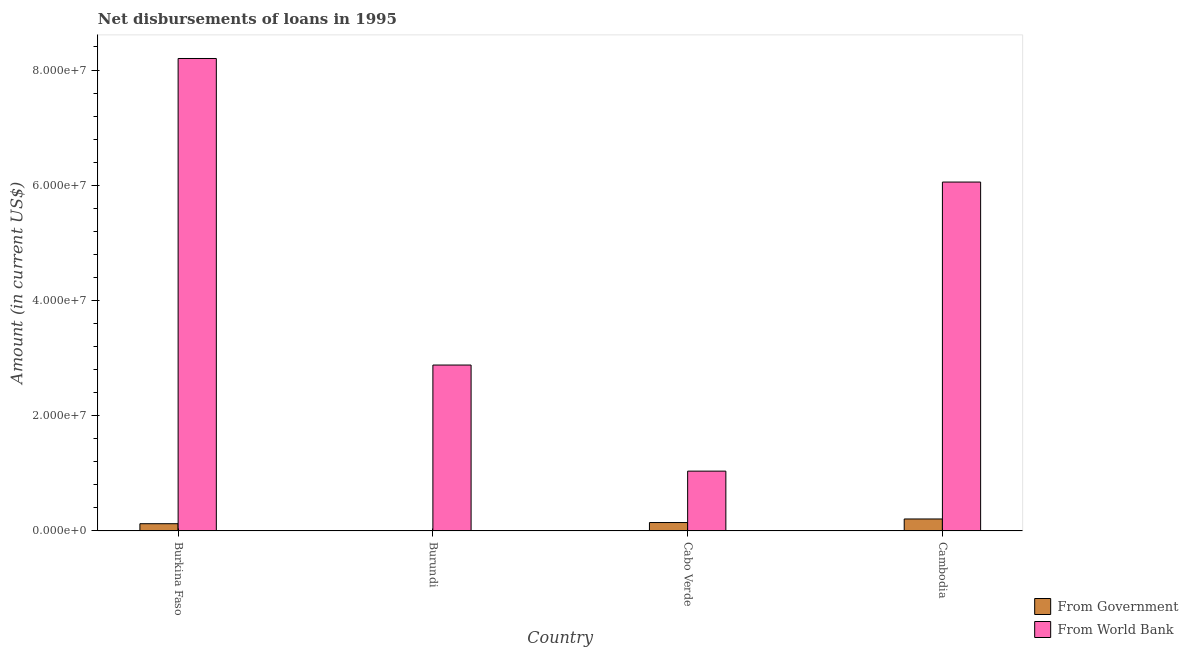Are the number of bars per tick equal to the number of legend labels?
Offer a very short reply. No. How many bars are there on the 4th tick from the left?
Give a very brief answer. 2. How many bars are there on the 3rd tick from the right?
Your response must be concise. 1. What is the label of the 2nd group of bars from the left?
Your answer should be very brief. Burundi. What is the net disbursements of loan from world bank in Cabo Verde?
Your answer should be very brief. 1.04e+07. Across all countries, what is the maximum net disbursements of loan from government?
Keep it short and to the point. 2.08e+06. Across all countries, what is the minimum net disbursements of loan from government?
Your answer should be compact. 0. In which country was the net disbursements of loan from world bank maximum?
Provide a short and direct response. Burkina Faso. What is the total net disbursements of loan from government in the graph?
Provide a short and direct response. 4.79e+06. What is the difference between the net disbursements of loan from world bank in Burundi and that in Cambodia?
Ensure brevity in your answer.  -3.18e+07. What is the difference between the net disbursements of loan from government in Burkina Faso and the net disbursements of loan from world bank in Burundi?
Provide a short and direct response. -2.75e+07. What is the average net disbursements of loan from world bank per country?
Offer a very short reply. 4.54e+07. What is the difference between the net disbursements of loan from world bank and net disbursements of loan from government in Cambodia?
Your answer should be compact. 5.85e+07. What is the ratio of the net disbursements of loan from world bank in Burkina Faso to that in Burundi?
Offer a terse response. 2.85. What is the difference between the highest and the second highest net disbursements of loan from government?
Keep it short and to the point. 6.19e+05. What is the difference between the highest and the lowest net disbursements of loan from government?
Provide a succinct answer. 2.08e+06. In how many countries, is the net disbursements of loan from world bank greater than the average net disbursements of loan from world bank taken over all countries?
Offer a terse response. 2. Is the sum of the net disbursements of loan from world bank in Burundi and Cabo Verde greater than the maximum net disbursements of loan from government across all countries?
Your response must be concise. Yes. Are the values on the major ticks of Y-axis written in scientific E-notation?
Your answer should be compact. Yes. Does the graph contain any zero values?
Offer a very short reply. Yes. Does the graph contain grids?
Provide a short and direct response. No. Where does the legend appear in the graph?
Provide a short and direct response. Bottom right. How many legend labels are there?
Your response must be concise. 2. What is the title of the graph?
Make the answer very short. Net disbursements of loans in 1995. What is the label or title of the X-axis?
Give a very brief answer. Country. What is the Amount (in current US$) of From Government in Burkina Faso?
Offer a terse response. 1.26e+06. What is the Amount (in current US$) in From World Bank in Burkina Faso?
Make the answer very short. 8.20e+07. What is the Amount (in current US$) in From World Bank in Burundi?
Ensure brevity in your answer.  2.88e+07. What is the Amount (in current US$) of From Government in Cabo Verde?
Provide a succinct answer. 1.46e+06. What is the Amount (in current US$) of From World Bank in Cabo Verde?
Your answer should be very brief. 1.04e+07. What is the Amount (in current US$) of From Government in Cambodia?
Ensure brevity in your answer.  2.08e+06. What is the Amount (in current US$) in From World Bank in Cambodia?
Provide a short and direct response. 6.06e+07. Across all countries, what is the maximum Amount (in current US$) of From Government?
Offer a terse response. 2.08e+06. Across all countries, what is the maximum Amount (in current US$) in From World Bank?
Your answer should be very brief. 8.20e+07. Across all countries, what is the minimum Amount (in current US$) of From World Bank?
Your answer should be compact. 1.04e+07. What is the total Amount (in current US$) of From Government in the graph?
Provide a short and direct response. 4.79e+06. What is the total Amount (in current US$) in From World Bank in the graph?
Your answer should be very brief. 1.82e+08. What is the difference between the Amount (in current US$) of From World Bank in Burkina Faso and that in Burundi?
Your response must be concise. 5.32e+07. What is the difference between the Amount (in current US$) of From Government in Burkina Faso and that in Cabo Verde?
Provide a short and direct response. -2.02e+05. What is the difference between the Amount (in current US$) in From World Bank in Burkina Faso and that in Cabo Verde?
Your response must be concise. 7.16e+07. What is the difference between the Amount (in current US$) of From Government in Burkina Faso and that in Cambodia?
Keep it short and to the point. -8.21e+05. What is the difference between the Amount (in current US$) of From World Bank in Burkina Faso and that in Cambodia?
Provide a short and direct response. 2.14e+07. What is the difference between the Amount (in current US$) in From World Bank in Burundi and that in Cabo Verde?
Offer a terse response. 1.84e+07. What is the difference between the Amount (in current US$) of From World Bank in Burundi and that in Cambodia?
Offer a terse response. -3.18e+07. What is the difference between the Amount (in current US$) in From Government in Cabo Verde and that in Cambodia?
Provide a succinct answer. -6.19e+05. What is the difference between the Amount (in current US$) of From World Bank in Cabo Verde and that in Cambodia?
Ensure brevity in your answer.  -5.02e+07. What is the difference between the Amount (in current US$) of From Government in Burkina Faso and the Amount (in current US$) of From World Bank in Burundi?
Keep it short and to the point. -2.75e+07. What is the difference between the Amount (in current US$) in From Government in Burkina Faso and the Amount (in current US$) in From World Bank in Cabo Verde?
Provide a succinct answer. -9.12e+06. What is the difference between the Amount (in current US$) in From Government in Burkina Faso and the Amount (in current US$) in From World Bank in Cambodia?
Give a very brief answer. -5.93e+07. What is the difference between the Amount (in current US$) of From Government in Cabo Verde and the Amount (in current US$) of From World Bank in Cambodia?
Your answer should be very brief. -5.91e+07. What is the average Amount (in current US$) of From Government per country?
Offer a very short reply. 1.20e+06. What is the average Amount (in current US$) of From World Bank per country?
Make the answer very short. 4.54e+07. What is the difference between the Amount (in current US$) in From Government and Amount (in current US$) in From World Bank in Burkina Faso?
Offer a very short reply. -8.07e+07. What is the difference between the Amount (in current US$) of From Government and Amount (in current US$) of From World Bank in Cabo Verde?
Your answer should be very brief. -8.92e+06. What is the difference between the Amount (in current US$) of From Government and Amount (in current US$) of From World Bank in Cambodia?
Your response must be concise. -5.85e+07. What is the ratio of the Amount (in current US$) of From World Bank in Burkina Faso to that in Burundi?
Your response must be concise. 2.85. What is the ratio of the Amount (in current US$) of From Government in Burkina Faso to that in Cabo Verde?
Keep it short and to the point. 0.86. What is the ratio of the Amount (in current US$) of From World Bank in Burkina Faso to that in Cabo Verde?
Your answer should be very brief. 7.9. What is the ratio of the Amount (in current US$) of From Government in Burkina Faso to that in Cambodia?
Your answer should be compact. 0.6. What is the ratio of the Amount (in current US$) in From World Bank in Burkina Faso to that in Cambodia?
Your answer should be very brief. 1.35. What is the ratio of the Amount (in current US$) of From World Bank in Burundi to that in Cabo Verde?
Give a very brief answer. 2.77. What is the ratio of the Amount (in current US$) of From World Bank in Burundi to that in Cambodia?
Your answer should be compact. 0.48. What is the ratio of the Amount (in current US$) in From Government in Cabo Verde to that in Cambodia?
Make the answer very short. 0.7. What is the ratio of the Amount (in current US$) of From World Bank in Cabo Verde to that in Cambodia?
Provide a succinct answer. 0.17. What is the difference between the highest and the second highest Amount (in current US$) of From Government?
Offer a terse response. 6.19e+05. What is the difference between the highest and the second highest Amount (in current US$) of From World Bank?
Provide a succinct answer. 2.14e+07. What is the difference between the highest and the lowest Amount (in current US$) in From Government?
Keep it short and to the point. 2.08e+06. What is the difference between the highest and the lowest Amount (in current US$) of From World Bank?
Make the answer very short. 7.16e+07. 